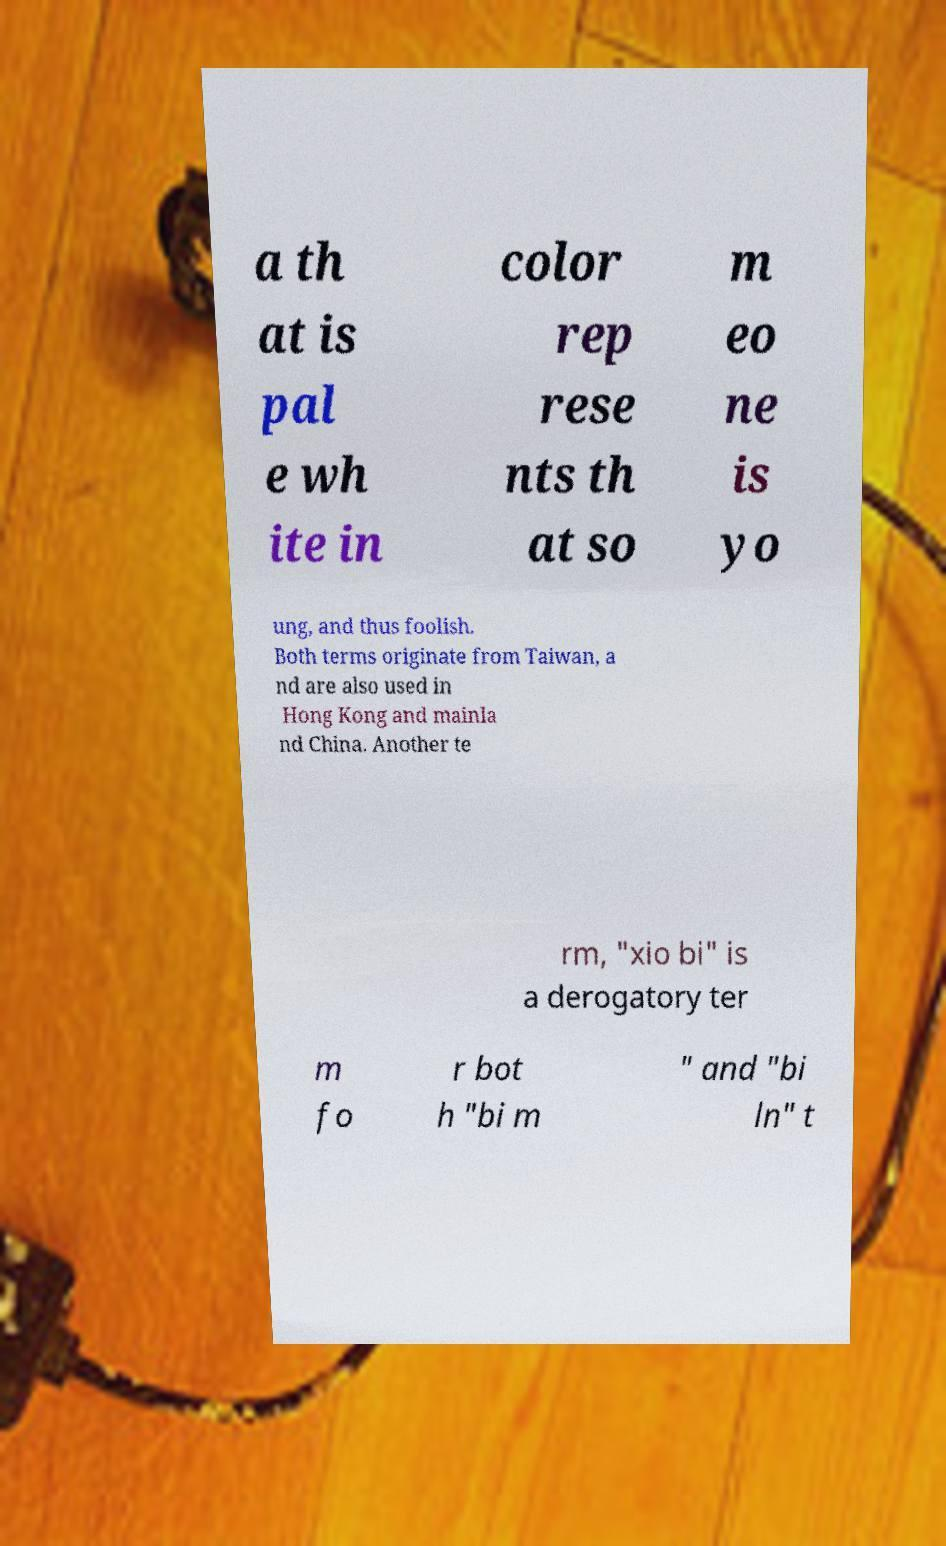Can you accurately transcribe the text from the provided image for me? a th at is pal e wh ite in color rep rese nts th at so m eo ne is yo ung, and thus foolish. Both terms originate from Taiwan, a nd are also used in Hong Kong and mainla nd China. Another te rm, "xio bi" is a derogatory ter m fo r bot h "bi m " and "bi ln" t 